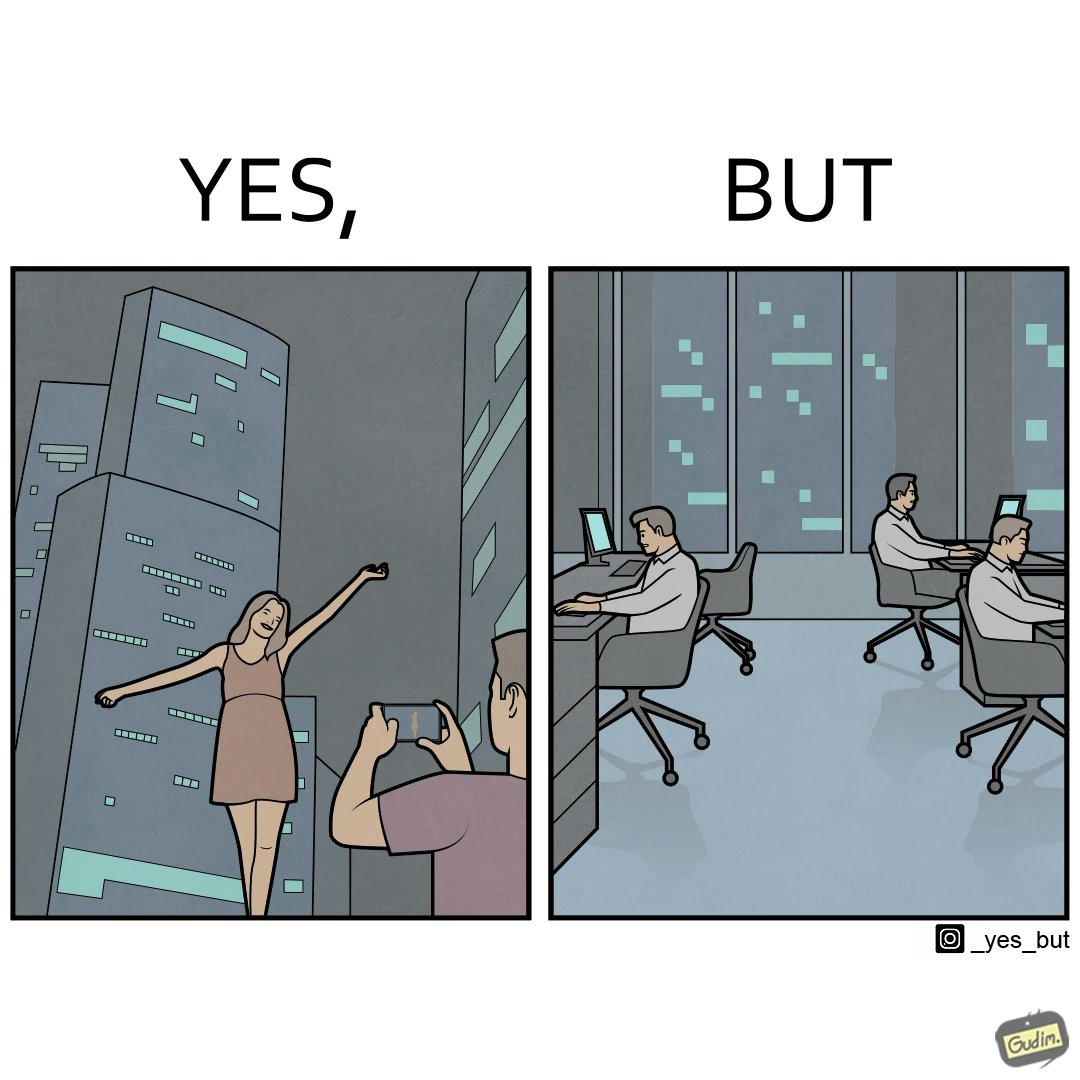Is this a satirical image? Yes, this image is satirical. 